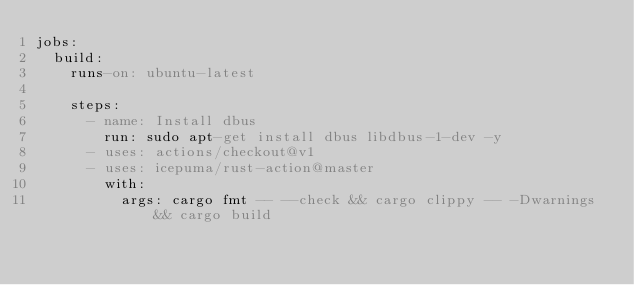<code> <loc_0><loc_0><loc_500><loc_500><_YAML_>jobs:
  build:
    runs-on: ubuntu-latest

    steps:
      - name: Install dbus
        run: sudo apt-get install dbus libdbus-1-dev -y
      - uses: actions/checkout@v1
      - uses: icepuma/rust-action@master
        with:
          args: cargo fmt -- --check && cargo clippy -- -Dwarnings && cargo build</code> 